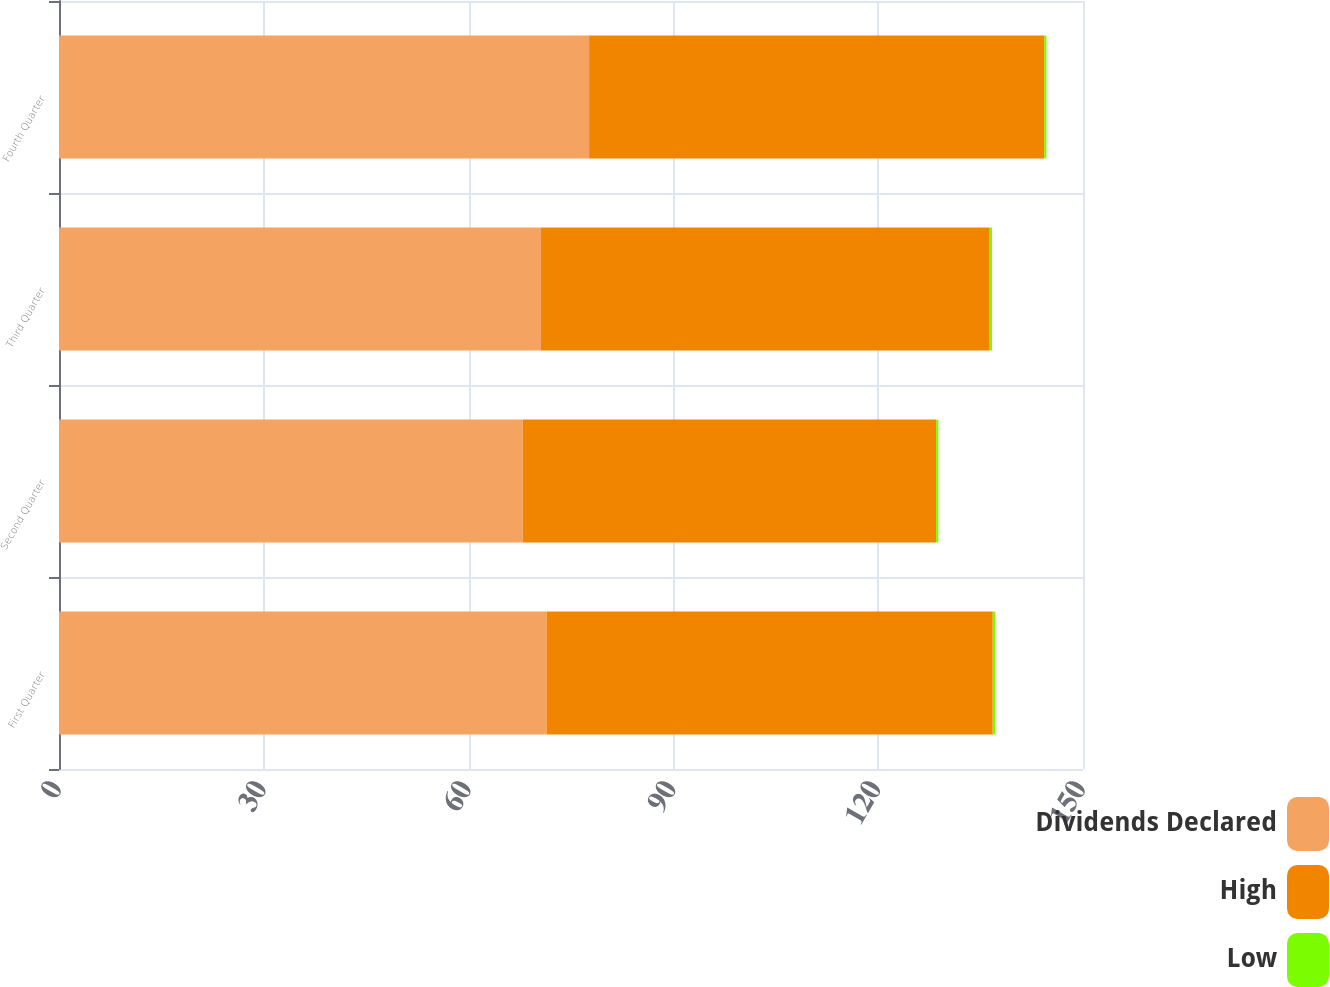Convert chart to OTSL. <chart><loc_0><loc_0><loc_500><loc_500><stacked_bar_chart><ecel><fcel>First Quarter<fcel>Second Quarter<fcel>Third Quarter<fcel>Fourth Quarter<nl><fcel>Dividends Declared<fcel>71.41<fcel>67.92<fcel>70.6<fcel>77.65<nl><fcel>High<fcel>65.37<fcel>60.56<fcel>65.74<fcel>66.66<nl><fcel>Low<fcel>0.33<fcel>0.33<fcel>0.33<fcel>0.33<nl></chart> 